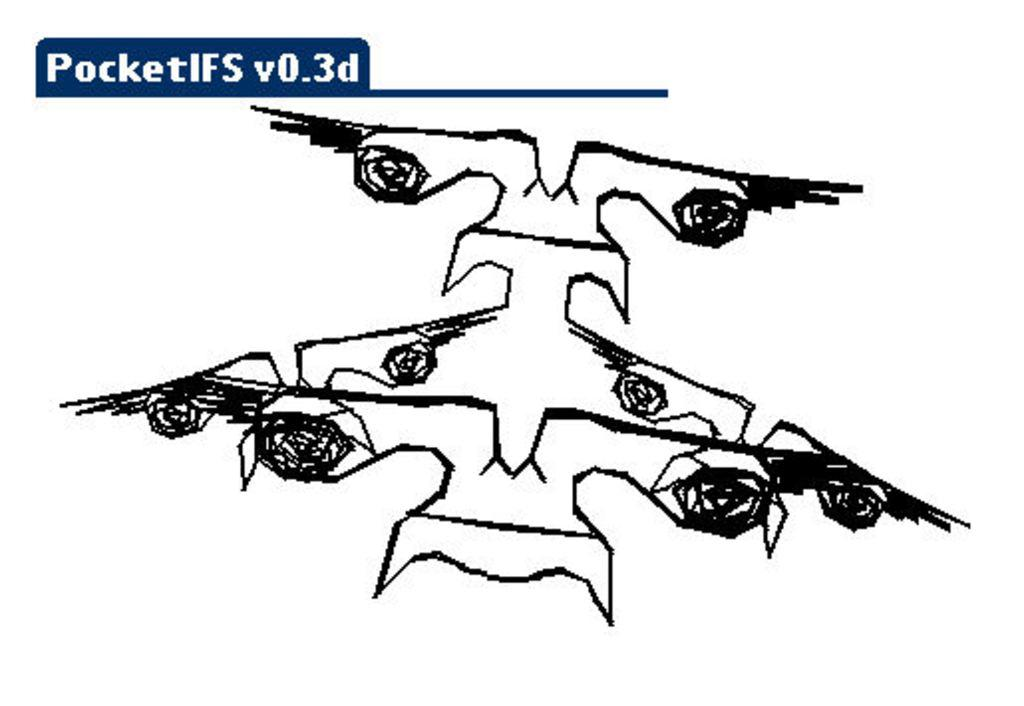What is the main content of the image? The image contains a drawing. Can you describe any text that is present in the image? There is text at the top of the image. What type of advertisement can be seen in the image? There is no advertisement present in the image; it contains a drawing and text. How many ducks are visible in the image? There are no ducks visible in the image. 